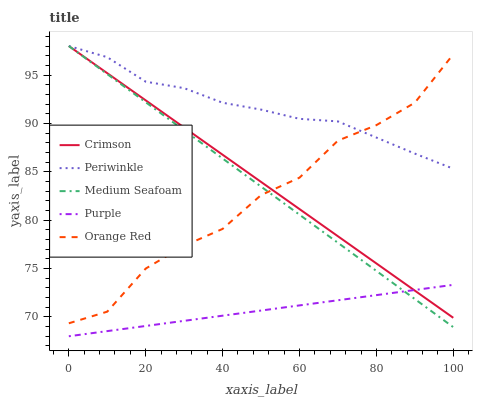Does Purple have the minimum area under the curve?
Answer yes or no. Yes. Does Periwinkle have the maximum area under the curve?
Answer yes or no. Yes. Does Periwinkle have the minimum area under the curve?
Answer yes or no. No. Does Purple have the maximum area under the curve?
Answer yes or no. No. Is Medium Seafoam the smoothest?
Answer yes or no. Yes. Is Orange Red the roughest?
Answer yes or no. Yes. Is Purple the smoothest?
Answer yes or no. No. Is Purple the roughest?
Answer yes or no. No. Does Purple have the lowest value?
Answer yes or no. Yes. Does Periwinkle have the lowest value?
Answer yes or no. No. Does Medium Seafoam have the highest value?
Answer yes or no. Yes. Does Purple have the highest value?
Answer yes or no. No. Is Purple less than Orange Red?
Answer yes or no. Yes. Is Orange Red greater than Purple?
Answer yes or no. Yes. Does Crimson intersect Purple?
Answer yes or no. Yes. Is Crimson less than Purple?
Answer yes or no. No. Is Crimson greater than Purple?
Answer yes or no. No. Does Purple intersect Orange Red?
Answer yes or no. No. 